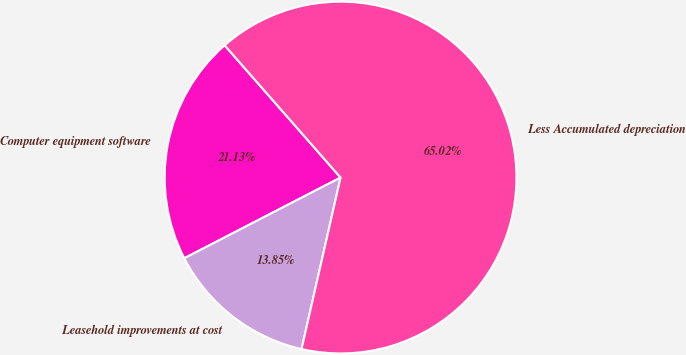<chart> <loc_0><loc_0><loc_500><loc_500><pie_chart><fcel>Computer equipment software<fcel>Leasehold improvements at cost<fcel>Less Accumulated depreciation<nl><fcel>21.13%<fcel>13.85%<fcel>65.01%<nl></chart> 